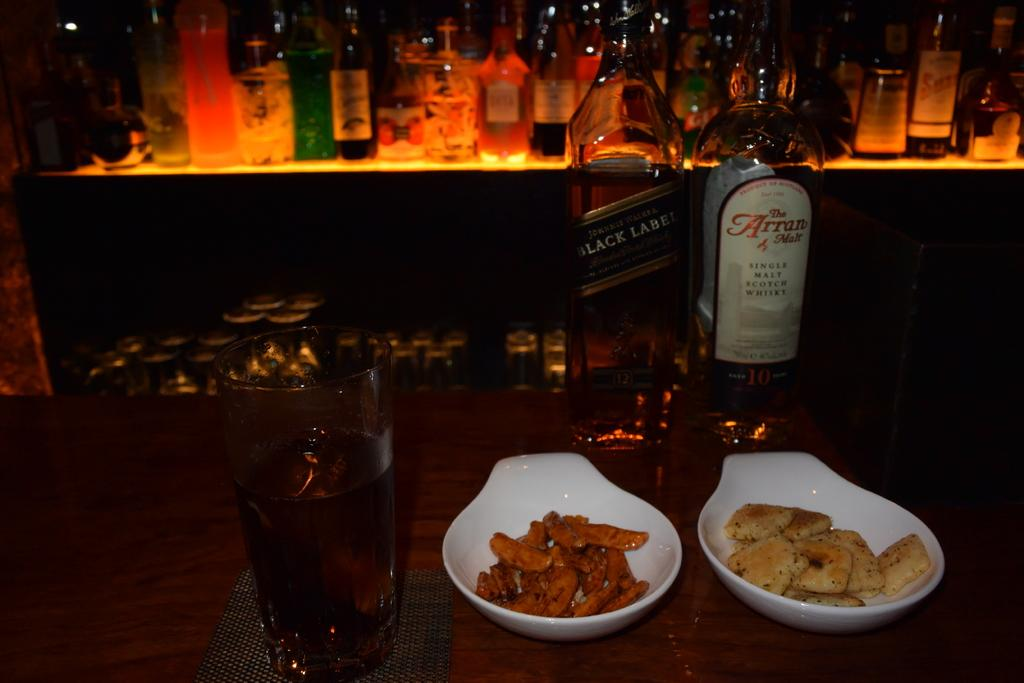Provide a one-sentence caption for the provided image. A bottle of black label and another of Arran malt sit behind bowls of food. 